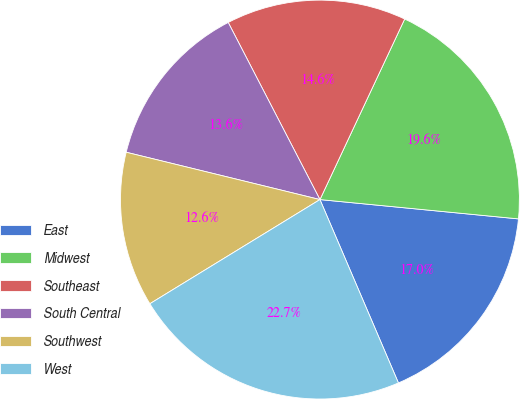<chart> <loc_0><loc_0><loc_500><loc_500><pie_chart><fcel>East<fcel>Midwest<fcel>Southeast<fcel>South Central<fcel>Southwest<fcel>West<nl><fcel>17.02%<fcel>19.56%<fcel>14.59%<fcel>13.58%<fcel>12.56%<fcel>22.69%<nl></chart> 